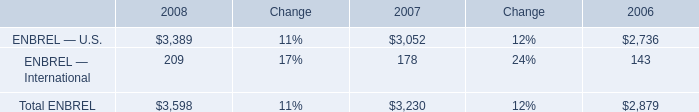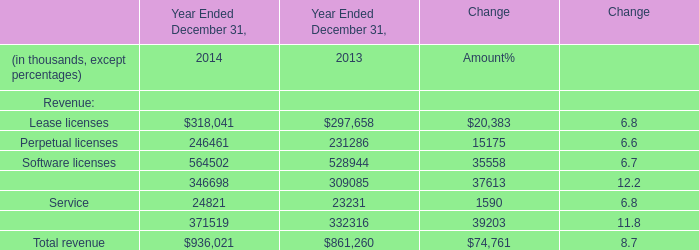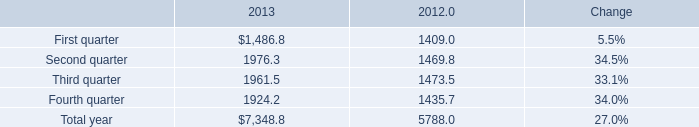what's the total amount of First quarter of 2013, and Maintenance of Year Ended December 31, 2014 ? 
Computations: (1486.8 + 346698.0)
Answer: 348184.8. 